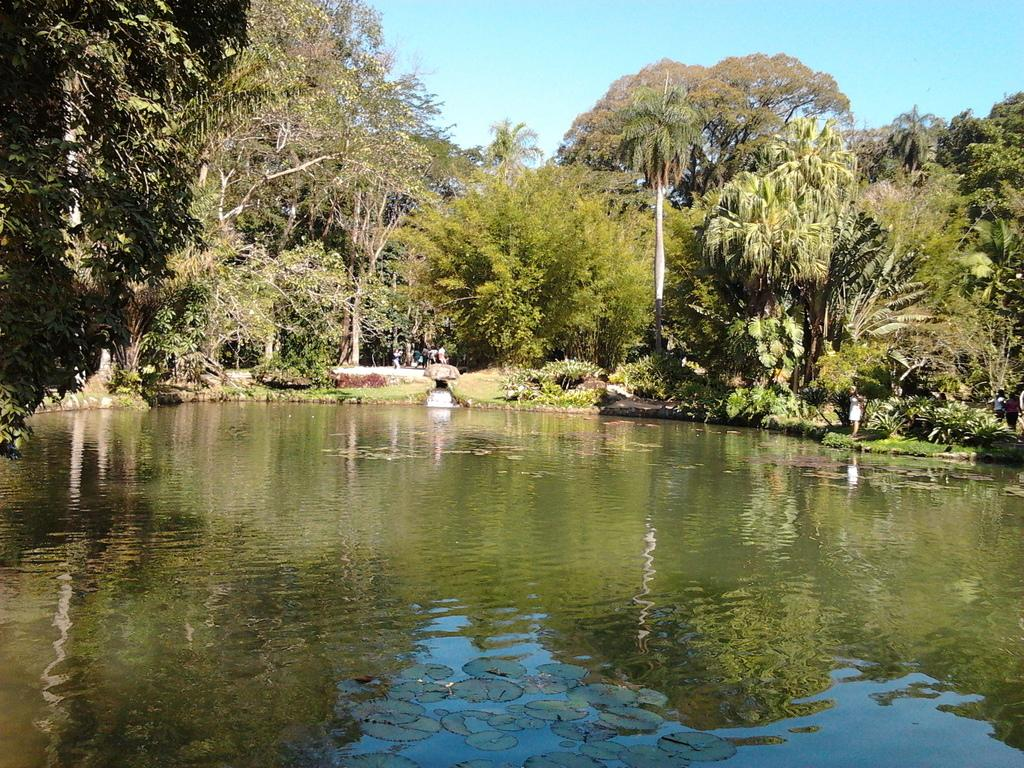What is one of the main elements visible in the image? Water is visible in the image. What type of natural environment is depicted in the image? There are many trees on both sides of the image, indicating a forest or wooded area. Can you describe the people in the image? There are a few people on the right side of the image. What else can be seen in the background of the image? There is a pole and the sky visible in the background of the image. What type of railway can be seen running through the water in the image? There is no railway present in the image; it only features water, trees, people, a pole, and the sky. 